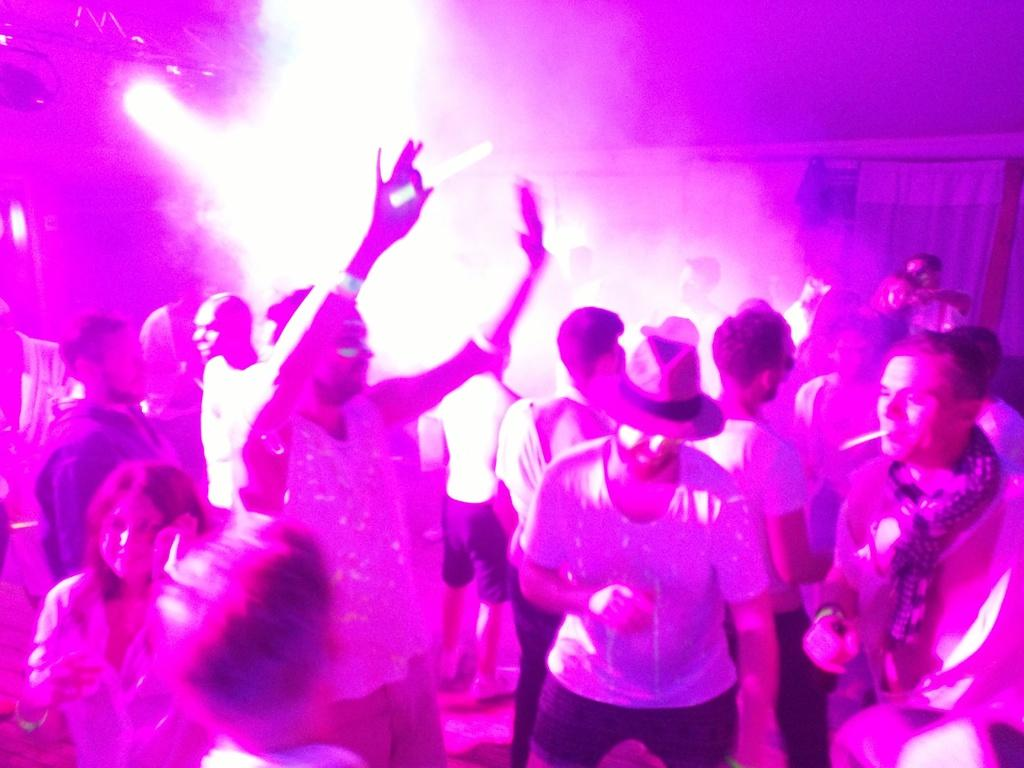Who or what can be seen in the image? There are people in the image. What can be seen in the background of the image? There are lights and a wall visible in the background of the image. What type of kite is being flown by the people in the image? There is no kite present in the image; it only features people and a background with lights and a wall. 